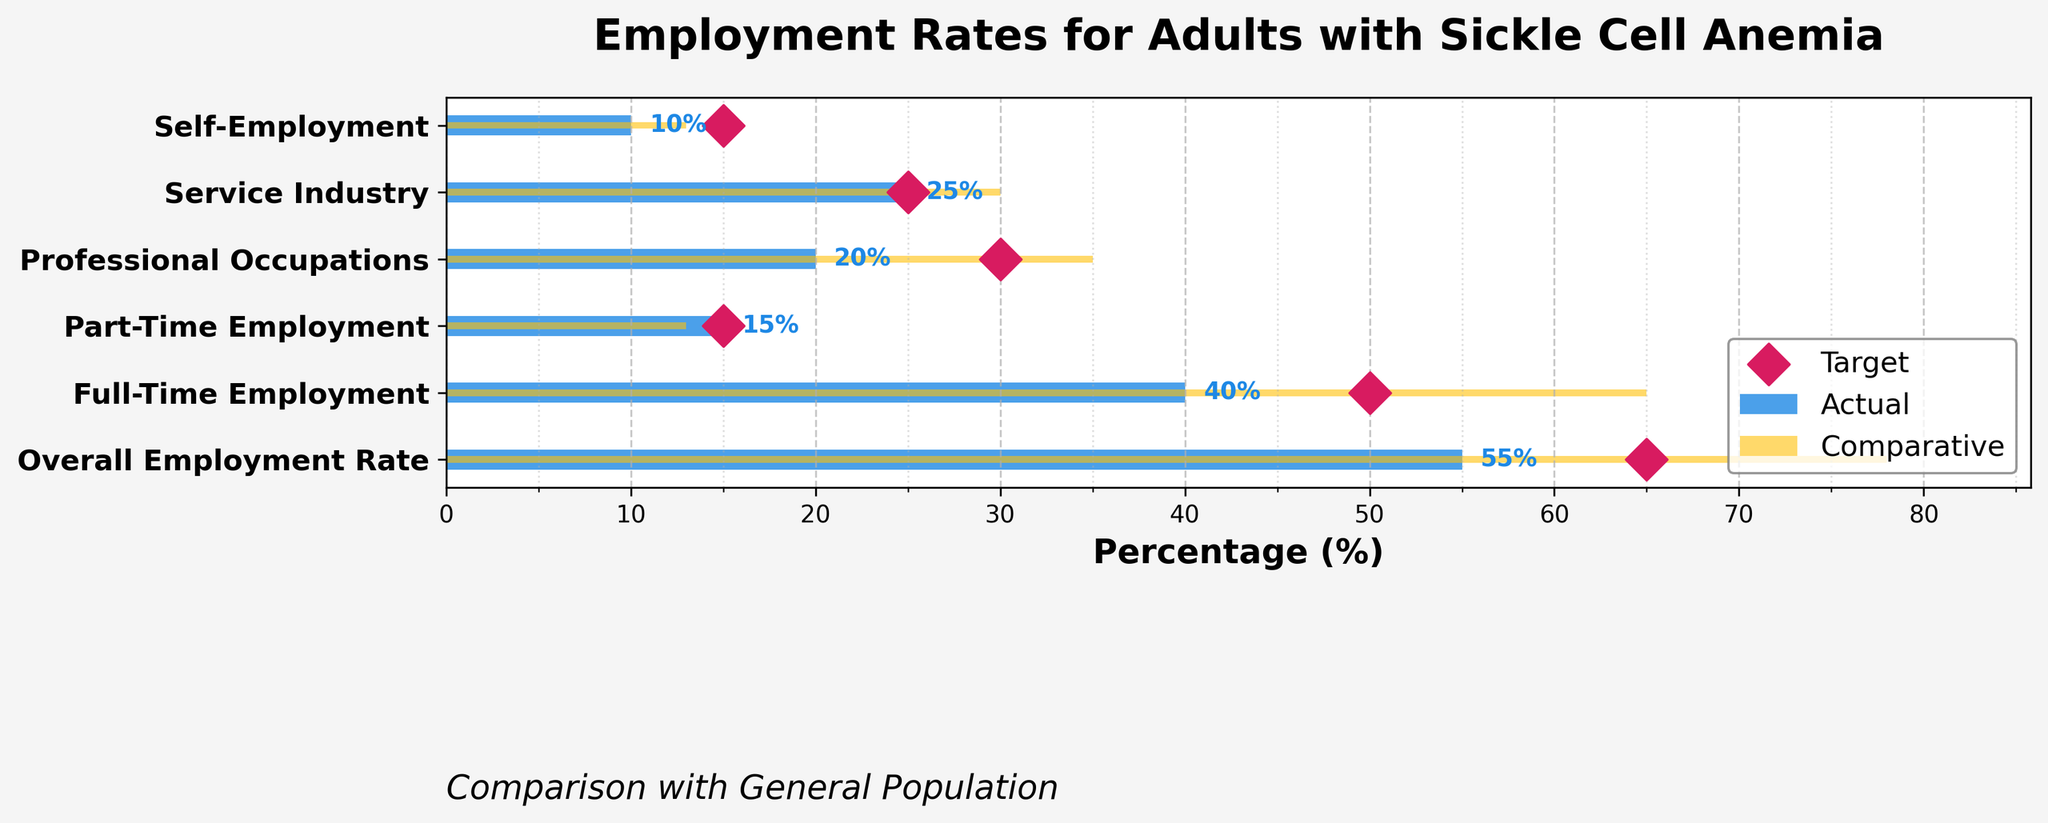What's the overall employment rate for adults with sickle cell anemia? Look at the bar representing "Overall Employment Rate" in the "Actual" section, it shows 55%
Answer: 55% How does the rate of full-time employment for adults with sickle cell anemia compare to the general population? Compare the two bars for "Full-Time Employment." The "Actual" value is 40%, and the "Comparative" value is 65%.
Answer: 40% vs 65% Is the target for self-employment for adults with sickle cell anemia met? Look at the "Self-Employment" category. The target marker is at 15%, and the actual bar is at 10%.
Answer: No What is the difference between the actual and target rates for professional occupations? Look at the "Professional Occupations" category. The actual rate is 20% and the target rate is 30%. Subtract 20 from 30 to find the difference: 30% - 20% = 10%.
Answer: 10% Among the categories listed, where do adults with sickle cell anemia meet the target rate? Compare the bars and target markers for each category. Only "Part-Time Employment" has the actual rate (15%) equal to the target (15%).
Answer: Part-Time Employment Which employment type shows the biggest gap between actual and comparative rates? Subtract the actual rates from the comparative rates in each category and find the maximum difference. The "Full-Time Employment" category has the biggest gap: 65% - 40% = 25%.
Answer: Full-Time Employment Are adults with sickle cell anemia closer to the target in service industry employment or self-employment? Compare the target markers and actual bars for "Service Industry" and "Self-Employment." Service industry actual is 25% and target is 25% (met); Self-employment actual is 10% and target is 15%.
Answer: Service Industry What is the average actual employment rate across all categories for adults with sickle cell anemia? Sum the actual rates and divide by the number of categories: (55+40+15+20+25+10) / 6 = 165 / 6 = 27.5%.
Answer: 27.5% What percentage point difference exists between the general population and adults with sickle cell anemia in the overall employment rate? Subtract the "Actual" value for "Overall Employment Rate" (55%) from the "Comparative" value (78%): 78% - 55% = 23%.
Answer: 23% Which employment category has the lowest actual rate for adults with sickle cell anemia? Find the smallest value in the "Actual" section. "Self-Employment" has the lowest actual rate at 10%.
Answer: Self-Employment 